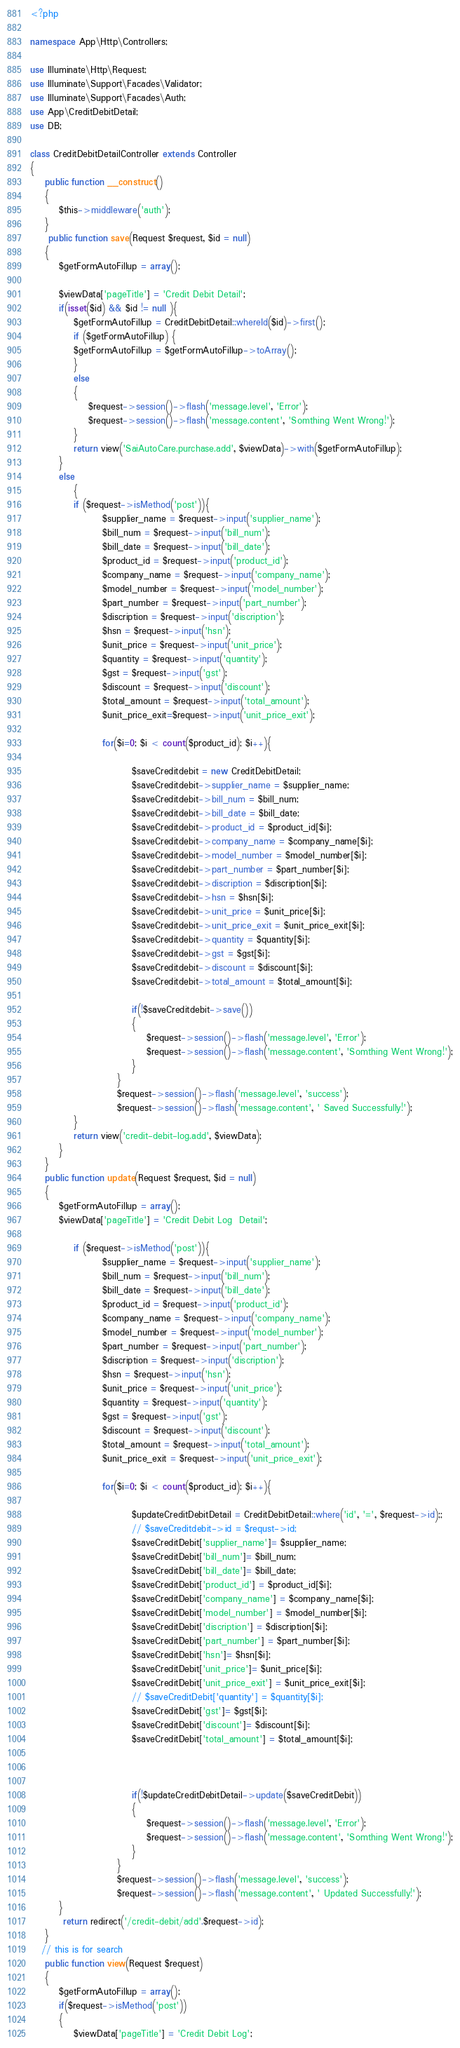<code> <loc_0><loc_0><loc_500><loc_500><_PHP_><?php

namespace App\Http\Controllers;

use Illuminate\Http\Request;
use Illuminate\Support\Facades\Validator;
use Illuminate\Support\Facades\Auth;
use App\CreditDebitDetail;
use DB;

class CreditDebitDetailController extends Controller
{
   	public function __construct()
    {
        $this->middleware('auth');
    }
     public function save(Request $request, $id = null)
    {
        $getFormAutoFillup = array();

        $viewData['pageTitle'] = 'Credit Debit Detail'; 
        if(isset($id) && $id != null ){
            $getFormAutoFillup = CreditDebitDetail::whereId($id)->first();           
            if ($getFormAutoFillup) {
            $getFormAutoFillup = $getFormAutoFillup->toArray();
            }
            else
            {
                $request->session()->flash('message.level', 'Error');
                $request->session()->flash('message.content', 'Somthing Went Wrong!');
            }
            return view('SaiAutoCare.purchase.add', $viewData)->with($getFormAutoFillup);
        }
        else
            {
            if ($request->isMethod('post')){    
                    $supplier_name = $request->input('supplier_name');
                    $bill_num = $request->input('bill_num');
                    $bill_date = $request->input('bill_date');
                    $product_id = $request->input('product_id');
                    $company_name = $request->input('company_name');
                    $model_number = $request->input('model_number');
                    $part_number = $request->input('part_number');
                    $discription = $request->input('discription');
                    $hsn = $request->input('hsn');
                    $unit_price = $request->input('unit_price');
                    $quantity = $request->input('quantity');
                    $gst = $request->input('gst');
                    $discount = $request->input('discount');
                    $total_amount = $request->input('total_amount');    
                    $unit_price_exit=$request->input('unit_price_exit');   

                    for($i=0; $i < count($product_id); $i++){

                            $saveCreditdebit = new CreditDebitDetail;
                            $saveCreditdebit->supplier_name = $supplier_name;
                            $saveCreditdebit->bill_num = $bill_num;
                            $saveCreditdebit->bill_date = $bill_date;
                            $saveCreditdebit->product_id = $product_id[$i];
                            $saveCreditdebit->company_name = $company_name[$i];
                            $saveCreditdebit->model_number = $model_number[$i];
                            $saveCreditdebit->part_number = $part_number[$i];
                            $saveCreditdebit->discription = $discription[$i];
                            $saveCreditdebit->hsn = $hsn[$i];
                            $saveCreditdebit->unit_price = $unit_price[$i];
                            $saveCreditdebit->unit_price_exit = $unit_price_exit[$i];
                            $saveCreditdebit->quantity = $quantity[$i];
                            $saveCreditdebit->gst = $gst[$i];
                            $saveCreditdebit->discount = $discount[$i];
                            $saveCreditdebit->total_amount = $total_amount[$i];

                            if(!$saveCreditdebit->save())
                            {
                                $request->session()->flash('message.level', 'Error');
                                $request->session()->flash('message.content', 'Somthing Went Wrong!');
                            }
                        }
                        $request->session()->flash('message.level', 'success');
                        $request->session()->flash('message.content', ' Saved Successfully!');
            }
            return view('credit-debit-log.add', $viewData);
        }
    }
    public function update(Request $request, $id = null)
    {
        $getFormAutoFillup = array();
        $viewData['pageTitle'] = 'Credit Debit Log  Detail'; 
       
            if ($request->isMethod('post')){    
                    $supplier_name = $request->input('supplier_name');
                    $bill_num = $request->input('bill_num');
                    $bill_date = $request->input('bill_date');
                    $product_id = $request->input('product_id');
                    $company_name = $request->input('company_name');
                    $model_number = $request->input('model_number');
                    $part_number = $request->input('part_number');
                    $discription = $request->input('discription');
                    $hsn = $request->input('hsn');
                    $unit_price = $request->input('unit_price');
                    $quantity = $request->input('quantity');
                    $gst = $request->input('gst');
                    $discount = $request->input('discount');
                    $total_amount = $request->input('total_amount');    
                    $unit_price_exit = $request->input('unit_price_exit');   

                    for($i=0; $i < count($product_id); $i++){
                        
                            $updateCreditDebitDetail = CreditDebitDetail::where('id', '=', $request->id);;
                            // $saveCreditdebit->id = $requst->id;
                            $saveCreditDebit['supplier_name']= $supplier_name;
                            $saveCreditDebit['bill_num']= $bill_num;
                            $saveCreditDebit['bill_date']= $bill_date;
                            $saveCreditDebit['product_id'] = $product_id[$i];
                            $saveCreditDebit['company_name'] = $company_name[$i];
                            $saveCreditDebit['model_number'] = $model_number[$i];
                            $saveCreditDebit['discription'] = $discription[$i];
                            $saveCreditDebit['part_number'] = $part_number[$i];
                            $saveCreditDebit['hsn']= $hsn[$i];
                            $saveCreditDebit['unit_price']= $unit_price[$i];
                            $saveCreditDebit['unit_price_exit'] = $unit_price_exit[$i];
                            // $saveCreditDebit['quantity'] = $quantity[$i];
                            $saveCreditDebit['gst']= $gst[$i];
                            $saveCreditDebit['discount']= $discount[$i];
                            $saveCreditDebit['total_amount'] = $total_amount[$i];

                            
 
                            if(!$updateCreditDebitDetail->update($saveCreditDebit))
                            {
                                $request->session()->flash('message.level', 'Error');
                                $request->session()->flash('message.content', 'Somthing Went Wrong!');
                            }
                        }
                        $request->session()->flash('message.level', 'success');
                        $request->session()->flash('message.content', ' Updated Successfully!');
        }
         return redirect('/credit-debit/add'.$request->id);
    }
   // this is for search
    public function view(Request $request)
    {
    	$getFormAutoFillup = array();
    	if($request->isMethod('post'))
    	{
    		$viewData['pageTitle'] = 'Credit Debit Log';       	</code> 